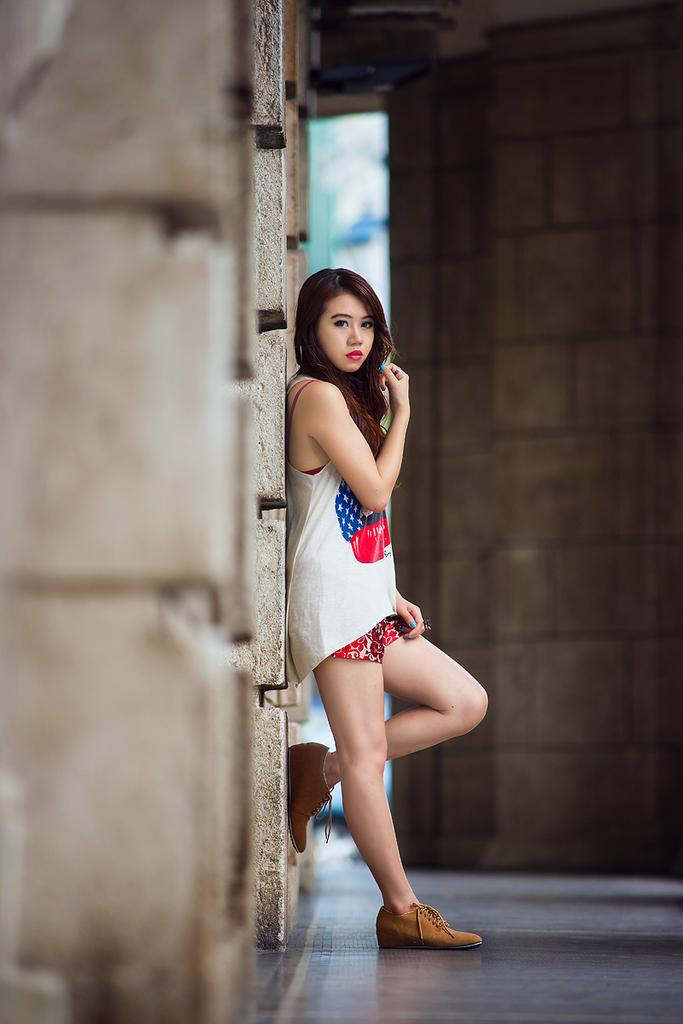Who is the main subject in the image? There is a girl in the image. Can you describe the girl's appearance? The girl is beautiful. What is the girl doing in the image? The girl is standing. What is the girl wearing on her upper body? The girl is wearing a white T-shirt. What type of shoes is the girl wearing? The girl is wearing brown shoes. What type of disease is the girl suffering from in the image? There is no indication of any disease in the image; the girl appears to be healthy and beautiful. Can you tell me how many beetles are crawling on the girl's shoes in the image? There are no beetles present in the image; the girl is wearing brown shoes. 